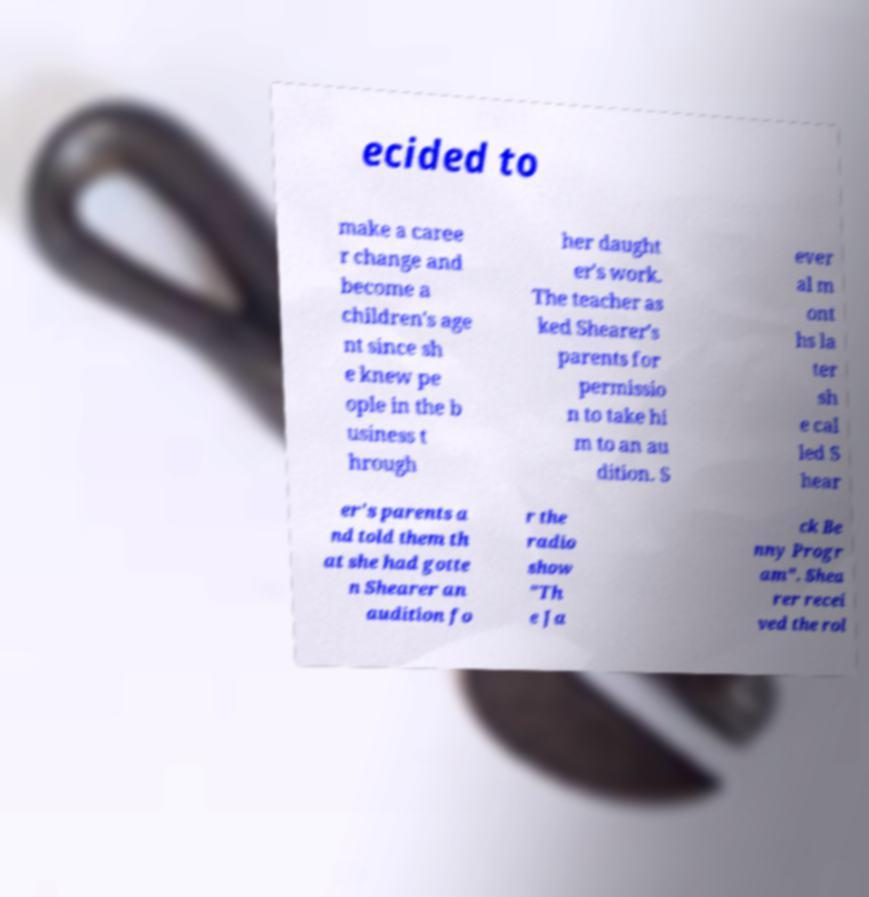Please read and relay the text visible in this image. What does it say? ecided to make a caree r change and become a children's age nt since sh e knew pe ople in the b usiness t hrough her daught er's work. The teacher as ked Shearer's parents for permissio n to take hi m to an au dition. S ever al m ont hs la ter sh e cal led S hear er's parents a nd told them th at she had gotte n Shearer an audition fo r the radio show "Th e Ja ck Be nny Progr am". Shea rer recei ved the rol 